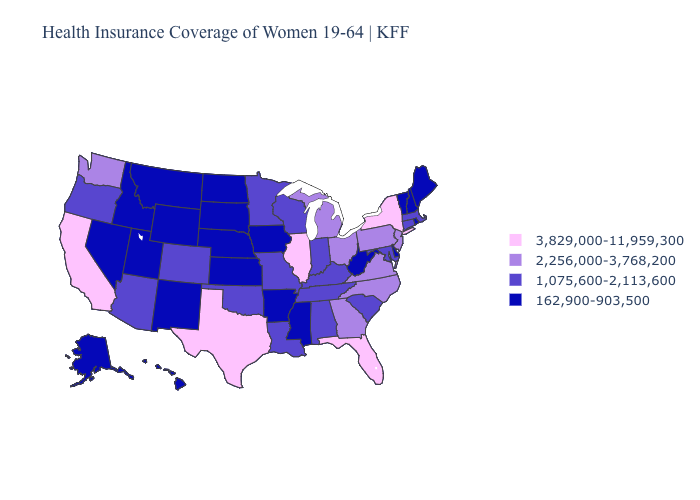What is the value of Tennessee?
Short answer required. 1,075,600-2,113,600. What is the value of Arizona?
Keep it brief. 1,075,600-2,113,600. Does the first symbol in the legend represent the smallest category?
Concise answer only. No. Does Kansas have the highest value in the USA?
Short answer required. No. Name the states that have a value in the range 3,829,000-11,959,300?
Quick response, please. California, Florida, Illinois, New York, Texas. What is the lowest value in the USA?
Answer briefly. 162,900-903,500. What is the lowest value in the USA?
Short answer required. 162,900-903,500. What is the highest value in states that border Colorado?
Give a very brief answer. 1,075,600-2,113,600. What is the value of Idaho?
Write a very short answer. 162,900-903,500. What is the lowest value in states that border Montana?
Concise answer only. 162,900-903,500. Does North Carolina have a higher value than North Dakota?
Short answer required. Yes. What is the value of Missouri?
Quick response, please. 1,075,600-2,113,600. What is the value of West Virginia?
Quick response, please. 162,900-903,500. What is the value of Georgia?
Quick response, please. 2,256,000-3,768,200. Which states hav the highest value in the MidWest?
Short answer required. Illinois. 